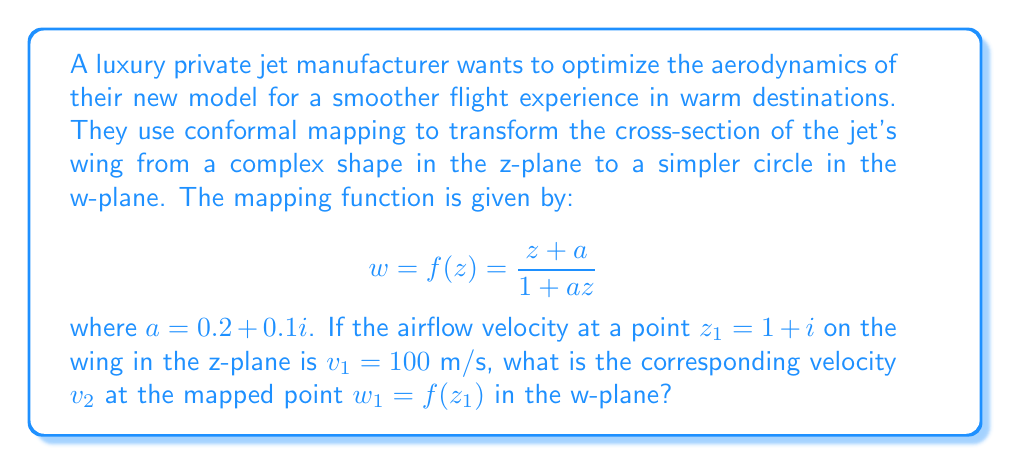Show me your answer to this math problem. To solve this problem, we'll use the property of conformal mappings that they preserve angles locally. This means that the velocity ratios at corresponding points in the z-plane and w-plane are equal to the magnitude of the derivative of the mapping function at that point.

Step 1: Calculate $w_1 = f(z_1)$
$$w_1 = f(z_1) = \frac{(1+i) + (0.2+0.1i)}{1 + (0.2+0.1i)(1+i)}$$
$$= \frac{1.2 + 1.1i}{1.2 + 0.3i}$$
$$= \frac{(1.2 + 1.1i)(1.2 - 0.3i)}{(1.2 + 0.3i)(1.2 - 0.3i)}$$
$$= \frac{1.44 + 1.32i - 0.36i + 0.33}{1.44 + 0.09}$$
$$= \frac{1.77 + 0.96i}{1.53}$$
$$\approx 1.157 + 0.627i$$

Step 2: Calculate the derivative of the mapping function
$$f'(z) = \frac{(1+az)-(z+a)a}{(1+az)^2} = \frac{1-a^2}{(1+az)^2}$$

Step 3: Evaluate $f'(z_1)$
$$f'(z_1) = \frac{1-(0.2+0.1i)^2}{(1+(0.2+0.1i)(1+i))^2}$$
$$= \frac{1-0.04-0.04i-0.01}{(1.2+0.3i)^2}$$
$$= \frac{0.95-0.04i}{1.44+0.72i-0.09}$$
$$= \frac{0.95-0.04i}{1.35+0.72i}$$
$$\approx 0.6715 - 0.1432i$$

Step 4: Calculate the magnitude of $f'(z_1)$
$$|f'(z_1)| = \sqrt{(0.6715)^2 + (-0.1432)^2} \approx 0.6868$$

Step 5: Use the velocity ratio property
$$\frac{v_2}{v_1} = |f'(z_1)|$$
$$v_2 = v_1 \cdot |f'(z_1)| = 100 \cdot 0.6868 \approx 68.68 \text{ m/s}$$

Therefore, the velocity at the mapped point $w_1$ in the w-plane is approximately 68.68 m/s.
Answer: The velocity $v_2$ at the mapped point $w_1$ in the w-plane is approximately 68.68 m/s. 